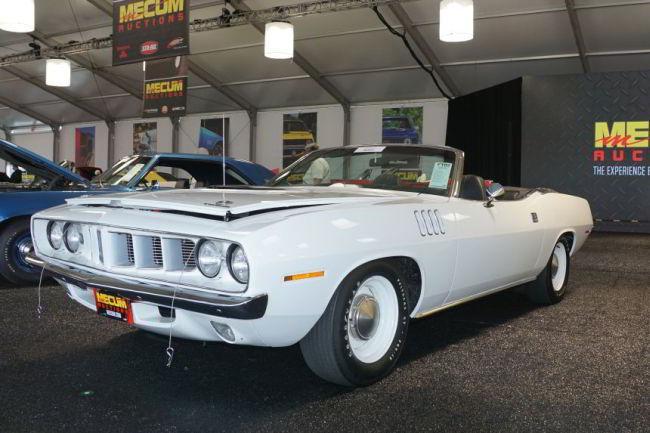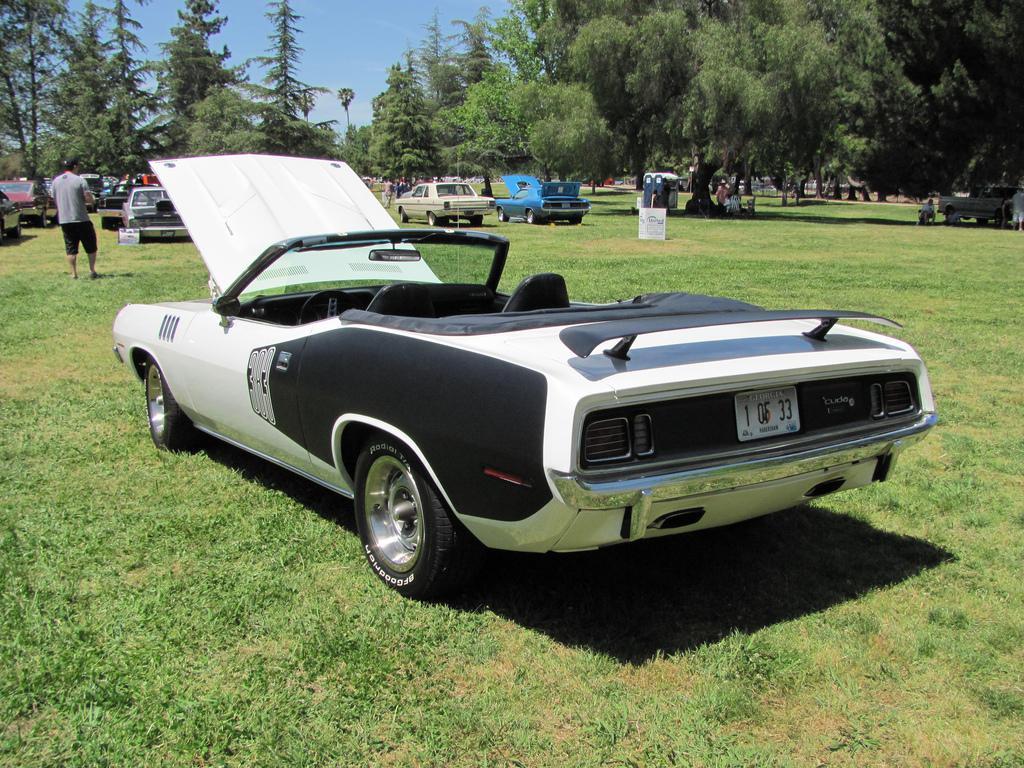The first image is the image on the left, the second image is the image on the right. Considering the images on both sides, is "Two predominantly white convertibles have the tops down, one facing towards the front and one to the back." valid? Answer yes or no. Yes. 